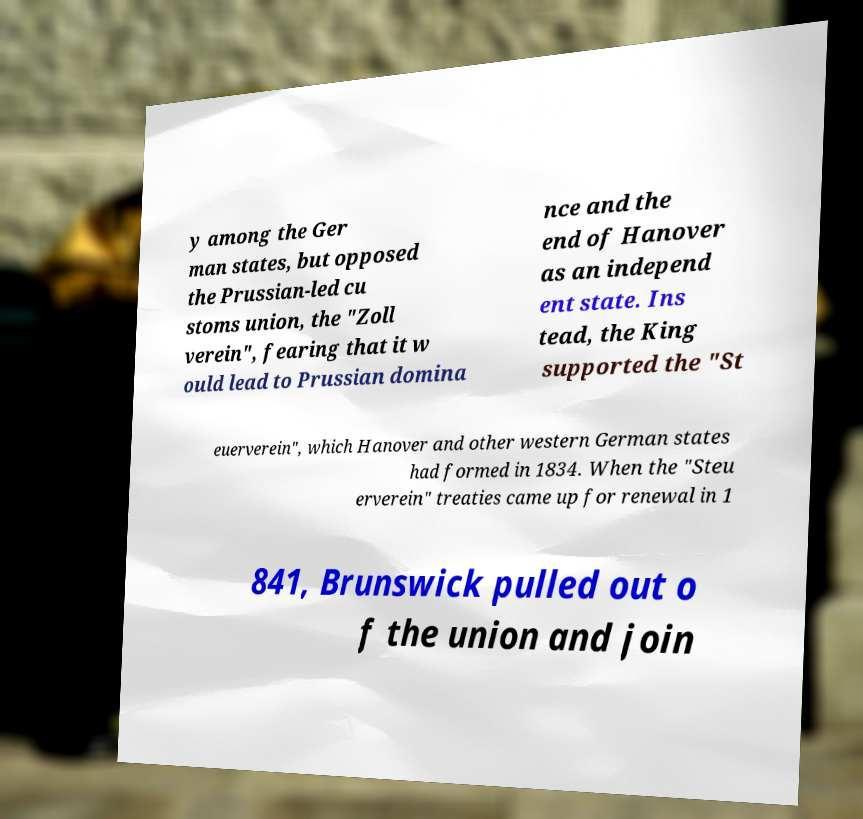Could you extract and type out the text from this image? y among the Ger man states, but opposed the Prussian-led cu stoms union, the "Zoll verein", fearing that it w ould lead to Prussian domina nce and the end of Hanover as an independ ent state. Ins tead, the King supported the "St euerverein", which Hanover and other western German states had formed in 1834. When the "Steu erverein" treaties came up for renewal in 1 841, Brunswick pulled out o f the union and join 